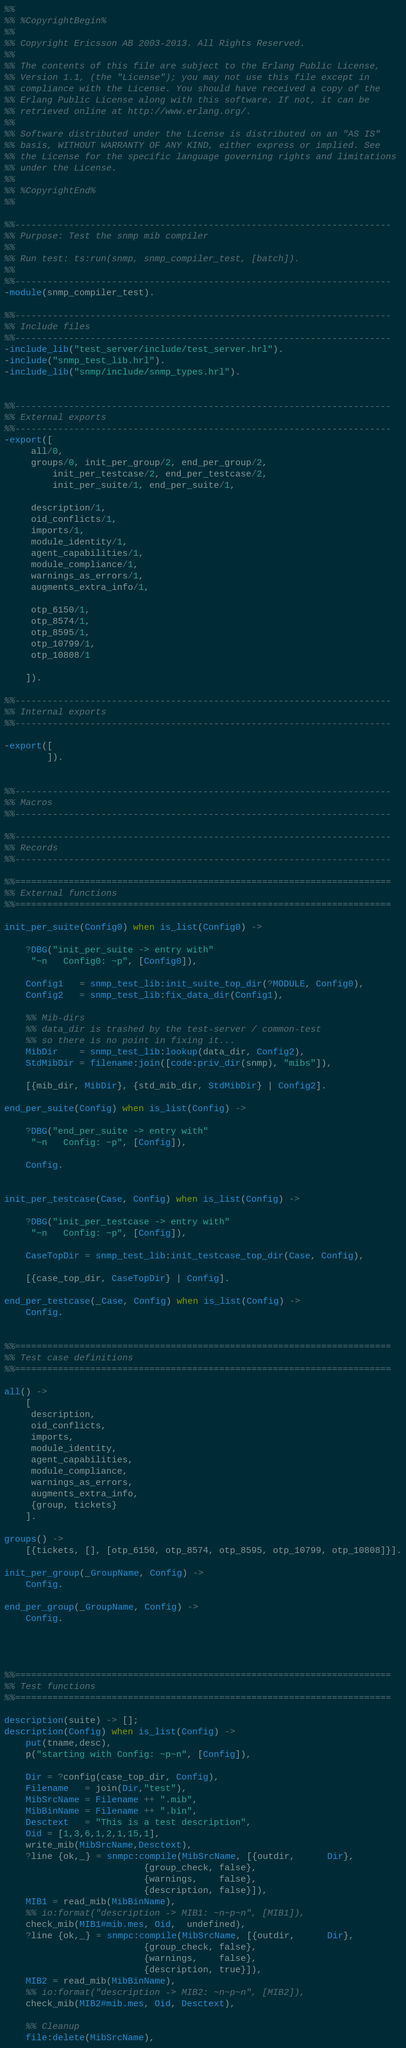Convert code to text. <code><loc_0><loc_0><loc_500><loc_500><_Erlang_>%% 
%% %CopyrightBegin%
%%
%% Copyright Ericsson AB 2003-2013. All Rights Reserved.
%%
%% The contents of this file are subject to the Erlang Public License,
%% Version 1.1, (the "License"); you may not use this file except in
%% compliance with the License. You should have received a copy of the
%% Erlang Public License along with this software. If not, it can be
%% retrieved online at http://www.erlang.org/.
%%
%% Software distributed under the License is distributed on an "AS IS"
%% basis, WITHOUT WARRANTY OF ANY KIND, either express or implied. See
%% the License for the specific language governing rights and limitations
%% under the License.
%%
%% %CopyrightEnd%
%% 

%%----------------------------------------------------------------------
%% Purpose: Test the snmp mib compiler
%% 
%% Run test: ts:run(snmp, snmp_compiler_test, [batch]).
%% 
%%----------------------------------------------------------------------
-module(snmp_compiler_test).

%%----------------------------------------------------------------------
%% Include files
%%----------------------------------------------------------------------
-include_lib("test_server/include/test_server.hrl").
-include("snmp_test_lib.hrl").
-include_lib("snmp/include/snmp_types.hrl").


%%----------------------------------------------------------------------
%% External exports
%%----------------------------------------------------------------------
-export([
	 all/0, 
	 groups/0, init_per_group/2, end_per_group/2, 
         init_per_testcase/2, end_per_testcase/2,
         init_per_suite/1, end_per_suite/1,

	 description/1,
	 oid_conflicts/1,
	 imports/1,
	 module_identity/1,
	 agent_capabilities/1,
	 module_compliance/1, 
	 warnings_as_errors/1,
	 augments_extra_info/1,

	 otp_6150/1,
	 otp_8574/1, 
	 otp_8595/1, 
	 otp_10799/1, 
	 otp_10808/1

	]).

%%----------------------------------------------------------------------
%% Internal exports
%%----------------------------------------------------------------------

-export([
        ]).


%%----------------------------------------------------------------------
%% Macros
%%----------------------------------------------------------------------

%%----------------------------------------------------------------------
%% Records
%%----------------------------------------------------------------------

%%======================================================================
%% External functions
%%======================================================================

init_per_suite(Config0) when is_list(Config0) ->

    ?DBG("init_per_suite -> entry with"
	 "~n   Config0: ~p", [Config0]),

    Config1   = snmp_test_lib:init_suite_top_dir(?MODULE, Config0), 
    Config2   = snmp_test_lib:fix_data_dir(Config1),

    %% Mib-dirs
    %% data_dir is trashed by the test-server / common-test
    %% so there is no point in fixing it...
    MibDir    = snmp_test_lib:lookup(data_dir, Config2),
    StdMibDir = filename:join([code:priv_dir(snmp), "mibs"]),

    [{mib_dir, MibDir}, {std_mib_dir, StdMibDir} | Config2].

end_per_suite(Config) when is_list(Config) ->

    ?DBG("end_per_suite -> entry with"
	 "~n   Config: ~p", [Config]),

    Config.


init_per_testcase(Case, Config) when is_list(Config) ->

    ?DBG("init_per_testcase -> entry with"
	 "~n   Config: ~p", [Config]),

    CaseTopDir = snmp_test_lib:init_testcase_top_dir(Case, Config), 

    [{case_top_dir, CaseTopDir} | Config].

end_per_testcase(_Case, Config) when is_list(Config) ->
    Config.


%%======================================================================
%% Test case definitions
%%======================================================================

all() -> 
    [
     description, 
     oid_conflicts, 
     imports, 
     module_identity, 
     agent_capabilities, 
     module_compliance, 
     warnings_as_errors,
     augments_extra_info, 
     {group, tickets}
    ].

groups() -> 
    [{tickets, [], [otp_6150, otp_8574, otp_8595, otp_10799, otp_10808]}].

init_per_group(_GroupName, Config) ->
    Config.

end_per_group(_GroupName, Config) ->
    Config.




%%======================================================================
%% Test functions
%%======================================================================

description(suite) -> [];
description(Config) when is_list(Config) ->
    put(tname,desc),
    p("starting with Config: ~p~n", [Config]),

    Dir = ?config(case_top_dir, Config),
    Filename   = join(Dir,"test"),
    MibSrcName = Filename ++ ".mib",
    MibBinName = Filename ++ ".bin",
    Desctext   = "This is a test description",
    Oid = [1,3,6,1,2,1,15,1],
    write_mib(MibSrcName,Desctext),
    ?line {ok,_} = snmpc:compile(MibSrcName, [{outdir,      Dir},
					      {group_check, false},
					      {warnings,    false},
					      {description, false}]),
    MIB1 = read_mib(MibBinName),
    %% io:format("description -> MIB1: ~n~p~n", [MIB1]),
    check_mib(MIB1#mib.mes, Oid,  undefined),
    ?line {ok,_} = snmpc:compile(MibSrcName, [{outdir,      Dir},
					      {group_check, false},
					      {warnings,    false},
					      {description, true}]),
    MIB2 = read_mib(MibBinName),
    %% io:format("description -> MIB2: ~n~p~n", [MIB2]),
    check_mib(MIB2#mib.mes, Oid, Desctext),

    %% Cleanup
    file:delete(MibSrcName),</code> 